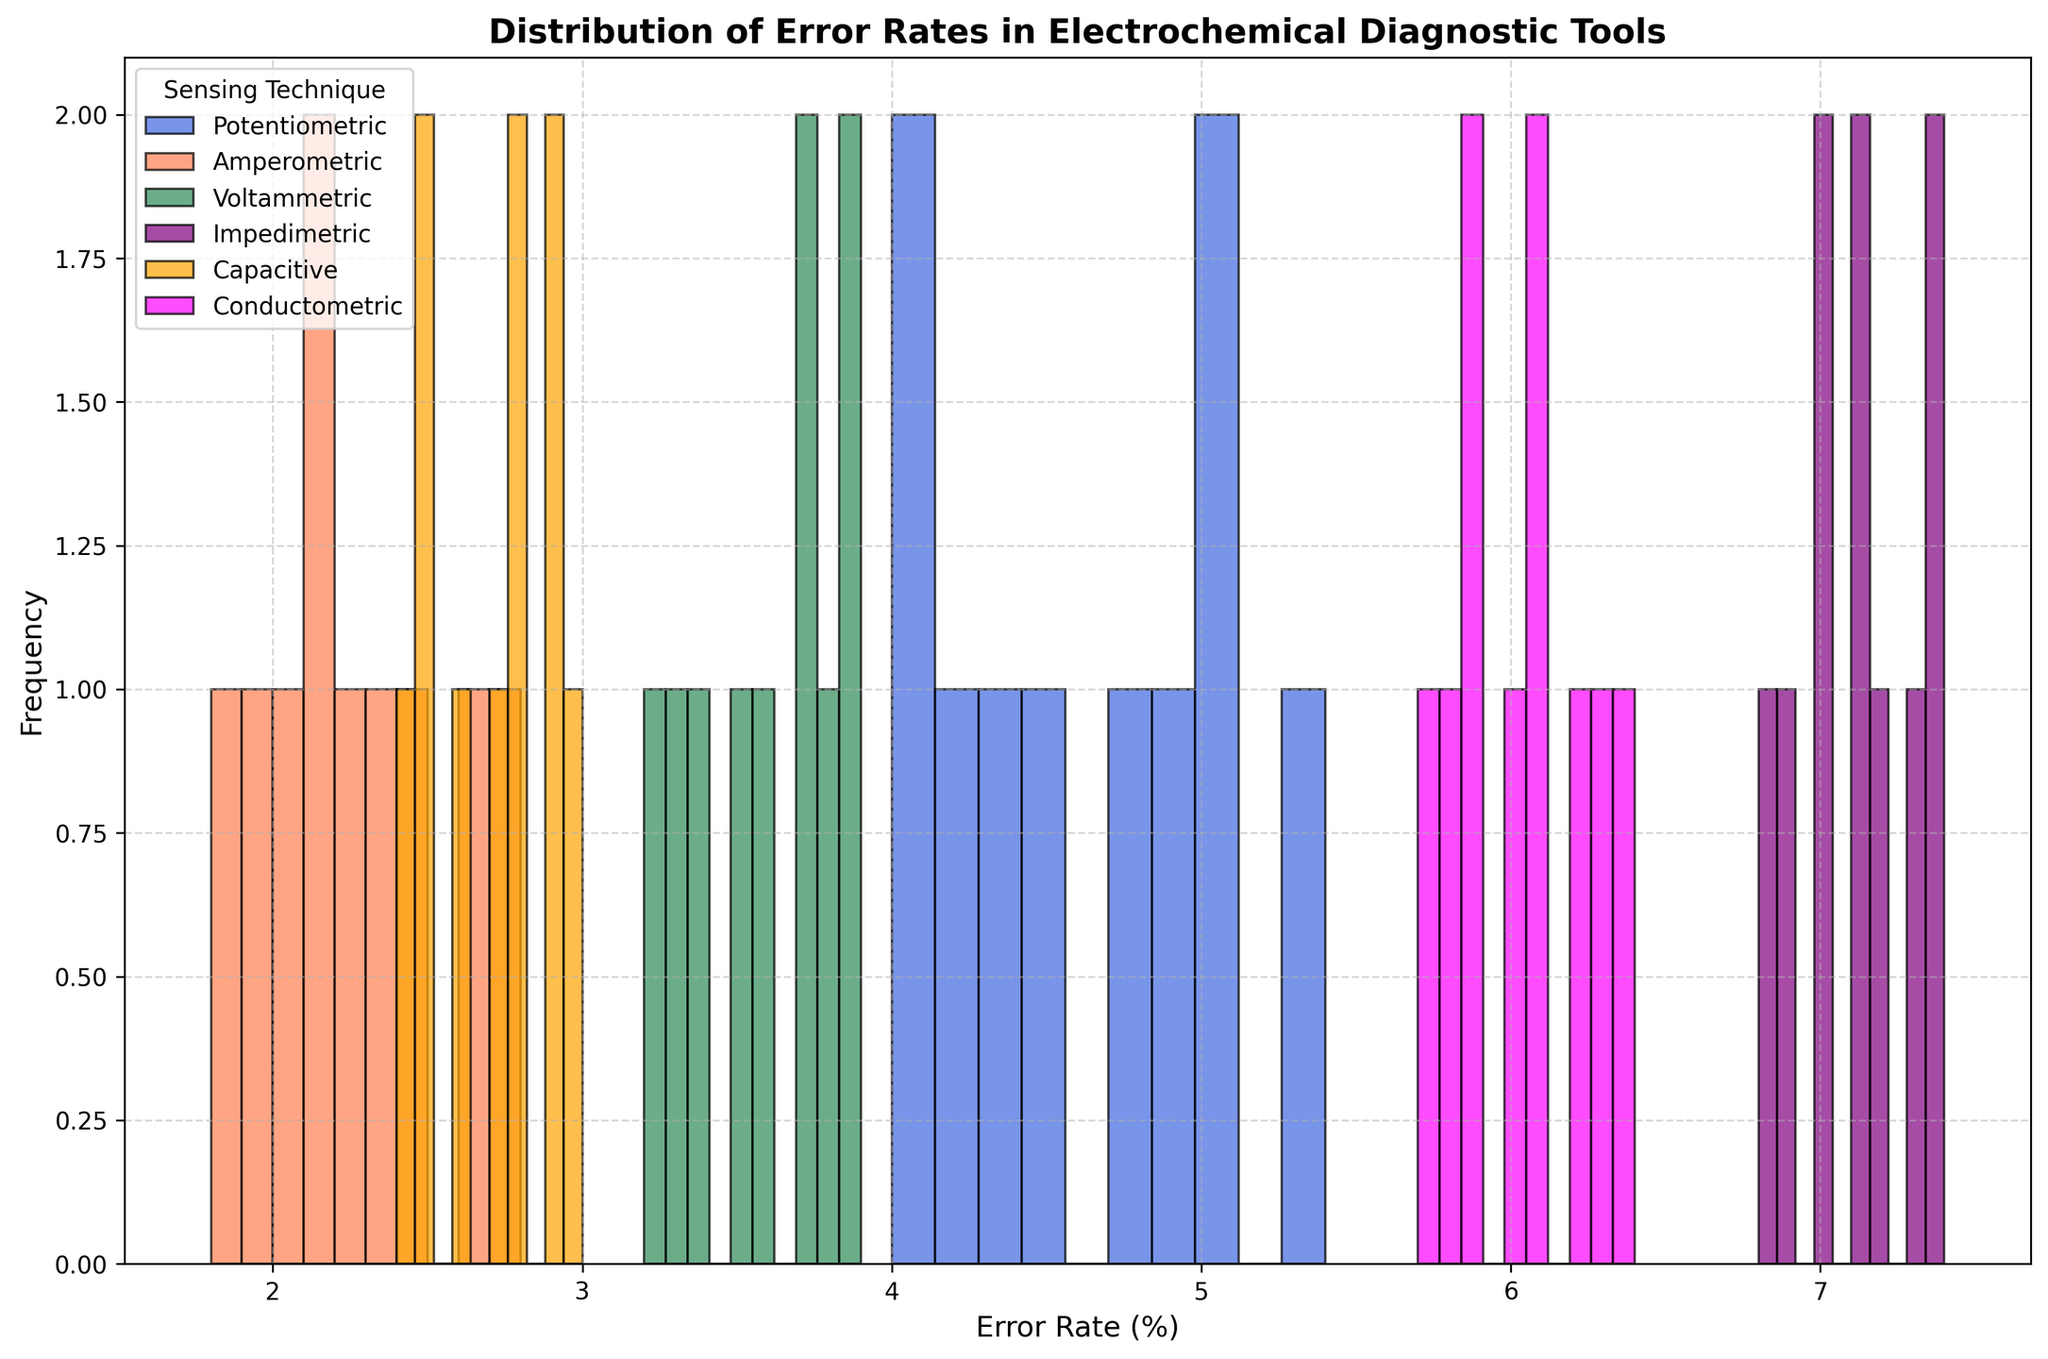What is the range of error rates for the potentiometric sensing technique? To find the range, identify the maximum and minimum error rates. The maximum error rate for potentiometric is 5.4% and the minimum is 4.0%. The range is computed as 5.4 - 4.0 = 1.4.
Answer: 1.4 Which sensing technique has the highest error rate and what is that rate? The error rates are represented by the heights of the bars. Impedimetric has bars reaching up to around 7.4%, which is the highest among all techniques shown in the plot.
Answer: Impedimetric, 7.4% Which sensing technique shows the most consistent error rates and how can you tell? Consistency can be interpreted as having the smallest range and a tightly clustered distribution. Capacitive sensing technique displays bars that are closely packed between 2.4% and 3.0%, suggesting it has the most consistent error rates.
Answer: Capacitive How do the error rates of amperometric and capacitive techniques compare? Amperometric error rates range between 1.8% to 2.8%, while capacitive ranges from 2.4% to 3.0%. The capacitor shows a slight upward shift in the error range.
Answer: Amperometric has lower error rates overall What is the most frequently occurring error rate range for voltammetric technique? The frequency is indicated by the height of the bars. For voltammetric, the histogram bars that occur most frequently are between 3.7% and 3.9%, where multiple counts reach their peak.
Answer: 3.7% - 3.9% How does the spread of error rates compare between conductometric and potentiometric sensing techniques? The spread is determined by the range of the error rates. Conductometric ranges from 5.7% to 6.4%, whereas potentiometric ranges from 4.0% to 5.4%. Conductometric has a narrower range compared to potentiometric.
Answer: Conductometric has a narrower spread What is the median error rate of the capacitive technique? The median is the middle value when the data points are ordered. For capacitive, the sorted error rates are 2.4, 2.5, 2.6, 2.7, 2.8, 2.8, 2.9, 3.0. Since there is an even number, the median is the average of the two middle values: (2.7 + 2.8) / 2 = 2.75.
Answer: 2.75 For which sensing technique is the interquartile range (IQR) the smallest, and what does this indicate about the distribution? IQR measures the middle spread and is the difference between the 75th and 25th percentiles. Capacitive has the smallest IQR, suggesting a more concentrated distribution of error rates.
Answer: Capacitive Which two sensing techniques have overlapping error rate distributions, and what implications might this have? Overlapping distributions indicate similar error rate ranges. Amperometric and capacitive overlap between 2.4% and 2.8%, suggesting they might provide similar diagnostic performance in some scenarios.
Answer: Amperometric and capacitive 